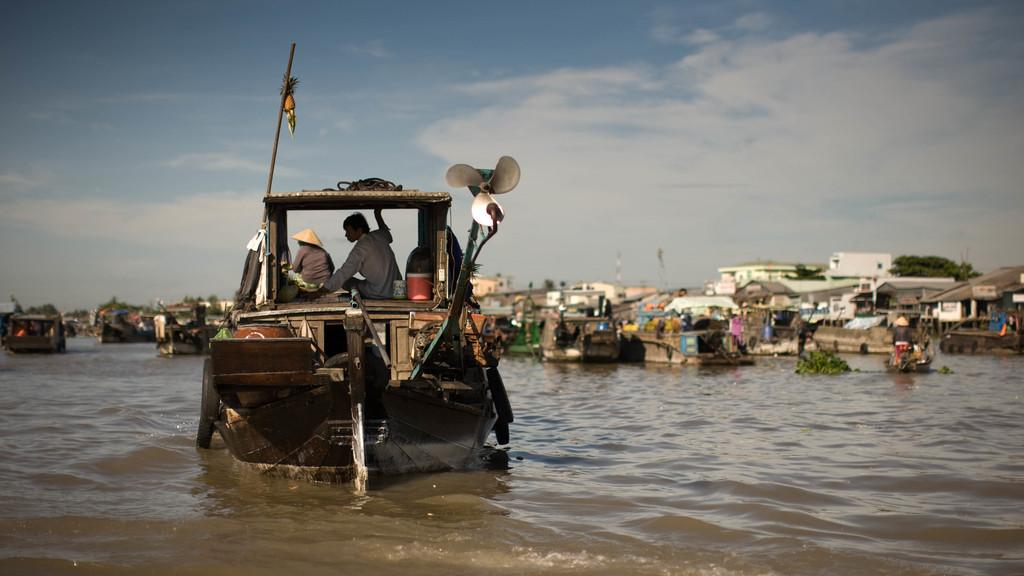What is at the bottom of the image? There is water at the bottom of the image. What can be seen floating on the water? There are boats in the image. Who or what is present in the boats? There are people in the image. What is visible above the boats and water? The sky is visible at the top of the image. What type of fuel is being used by the boats in the image? There is no information about the type of fuel being used by the boats in the image. Can you tell me how much lead is present in the water in the image? There is no mention of lead in the water in the image, and therefore it cannot be determined. 